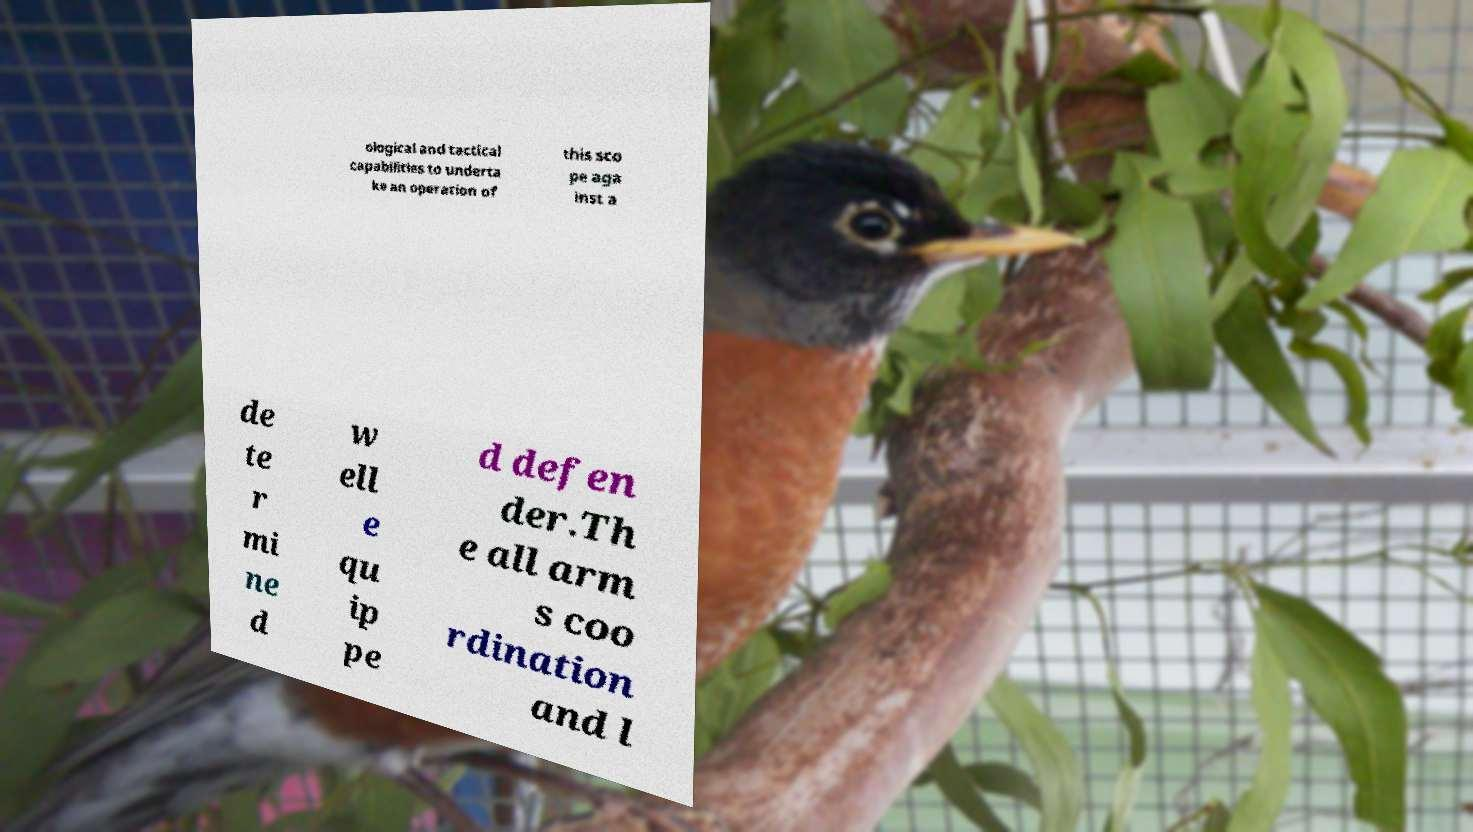Could you extract and type out the text from this image? ological and tactical capabilities to underta ke an operation of this sco pe aga inst a de te r mi ne d w ell e qu ip pe d defen der.Th e all arm s coo rdination and l 